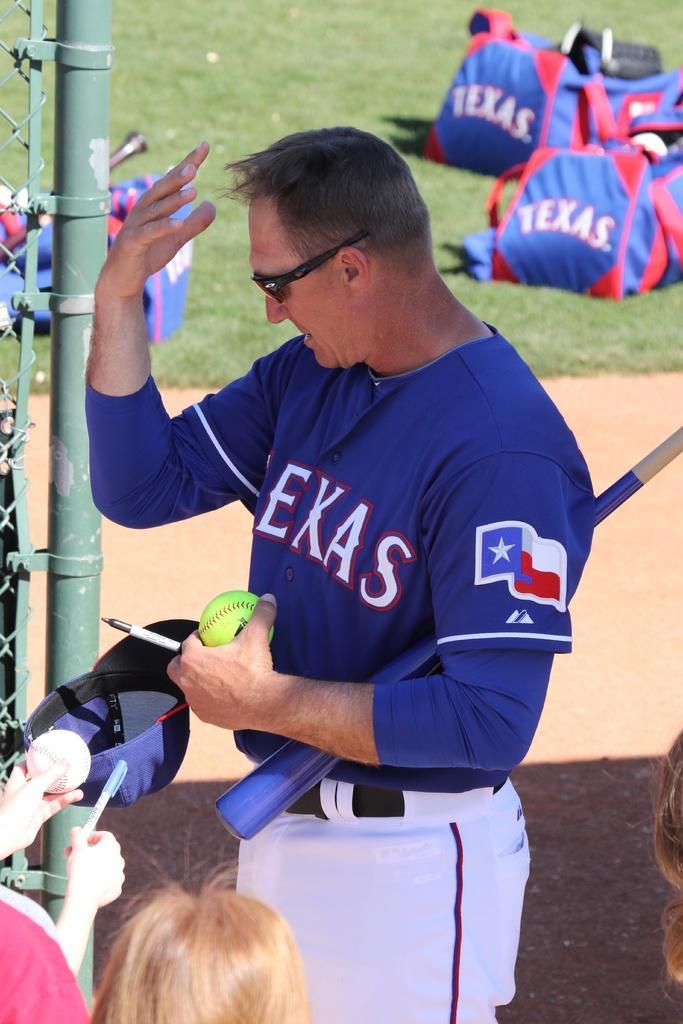Can you describe this image briefly? In this picture in the front there are persons and there is a man holding a baseball bat and ball and a pen in his hand. In the center there is a pole which is green in colour and on the left side there is a fence. In the background there are bags with some text written on it and there is grass on the ground. 